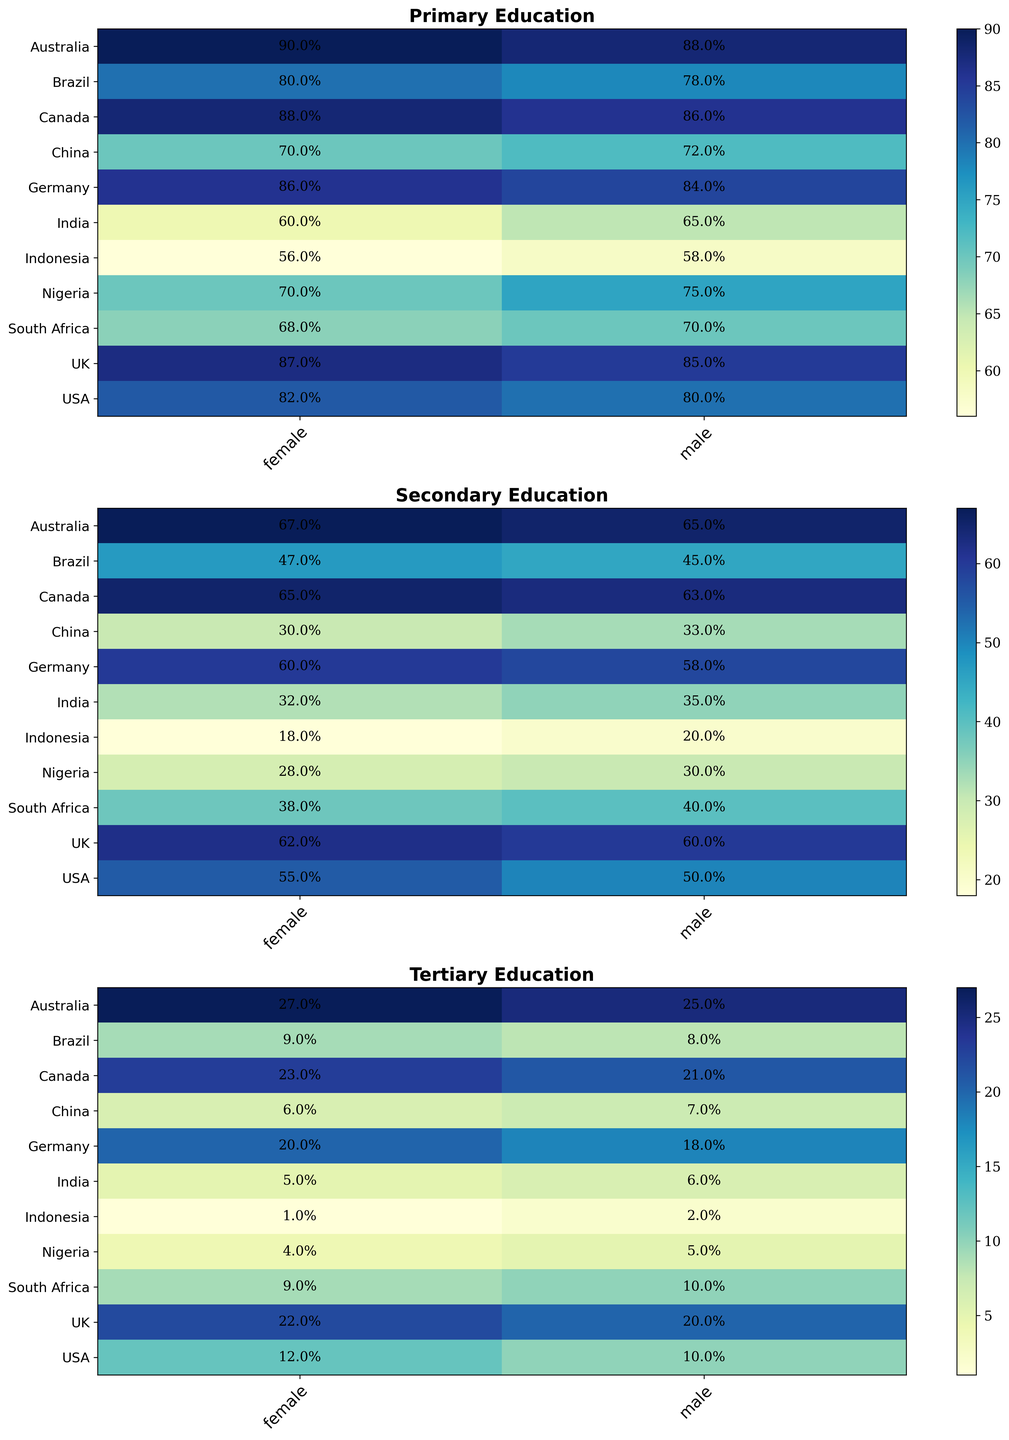What country has the highest percentage of albino females completing primary education? Look at the 'Primary Education' heatmap. Identify the country with the darkest blue shade in the 'female' column. The highest percentage is for Australia at 90%.
Answer: Australia Which gender in the UK has a higher percentage of albino individuals completing tertiary education? Compare the percentages in the 'Tertiary Education' heatmap for the male and female columns in the UK row. Females (22%) have a higher percentage than males (20%).
Answer: Female What is the difference in the percentage of albino males completing secondary education between USA and Brazil? First find the percentage of secondary education completion for males in USA (50%) and Brazil (45%). Subtract the smaller percentage from the larger one: 50 - 45 = 5.
Answer: 5% On average, do albino females or males have a higher percentage of completing tertiary education in Canada and Australia? Check the percentages for Canada: male (21%) and female (23%), and for Australia: male (25%) and female (27%). Calculate the average for females: (23+27)/2 = 25. Calculate the average for males: (21+25)/2 = 23. So females have a higher average.
Answer: Females Which country has the smallest gender gap in secondary education attainment among albinos? Calculate the absolute difference between males' and females' percentages for each country in the 'Secondary Education' heatmap. The smallest difference is in South Africa, where males are 40% and females are 38%, with a gap of 2.
Answer: South Africa What is the total percentage of albino females in China attaining primary and secondary education levels? Sum up the percentages shown for primary (70%) and secondary (30%) education for females in China: 70 + 30 = 100.
Answer: 100% Which country has the least proportion of albino females attaining tertiary education? From the 'Tertiary Education' heatmap, locate the country with the lightest shade of blue for the female column, which indicates the lowest percentage. The smallest value is from Indonesia (1%).
Answer: Indonesia In which educational level and country do albino males in Brazil most excel compared to albino females? Compare the differences in percentages between males and females in Brazil for primary (78% vs 80%), secondary (45% vs 47%), tertiary (8% vs 9%). The smallest difference is in primary education: 80 - 78 = 2. Thus, males in primary education have the smallest gender differential.
Answer: Primary Education, Brazil Which country shows the largest gender disparity in tertiary education among albinos? Calculate the absolute differences in the 'Tertiary Education' heatmap between males and females for each country. The largest gender disparity is found in Australia, where males are 25% and females are 27%, with a gap of 2.
Answer: Australia 